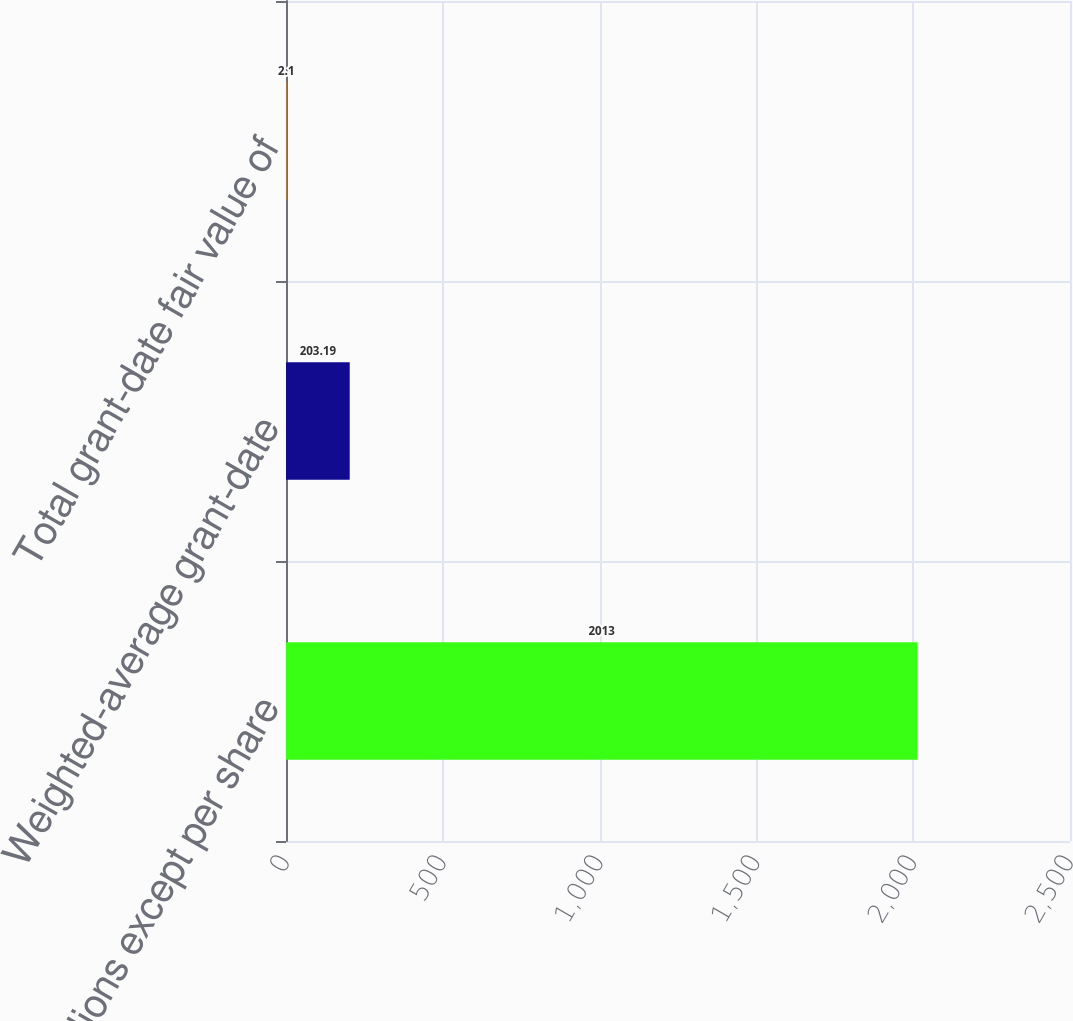Convert chart. <chart><loc_0><loc_0><loc_500><loc_500><bar_chart><fcel>In millions except per share<fcel>Weighted-average grant-date<fcel>Total grant-date fair value of<nl><fcel>2013<fcel>203.19<fcel>2.1<nl></chart> 